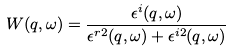<formula> <loc_0><loc_0><loc_500><loc_500>W ( q , \omega ) = \frac { \epsilon ^ { i } ( q , \omega ) } { \epsilon ^ { r 2 } ( q , \omega ) + \epsilon ^ { i 2 } ( q , \omega ) }</formula> 